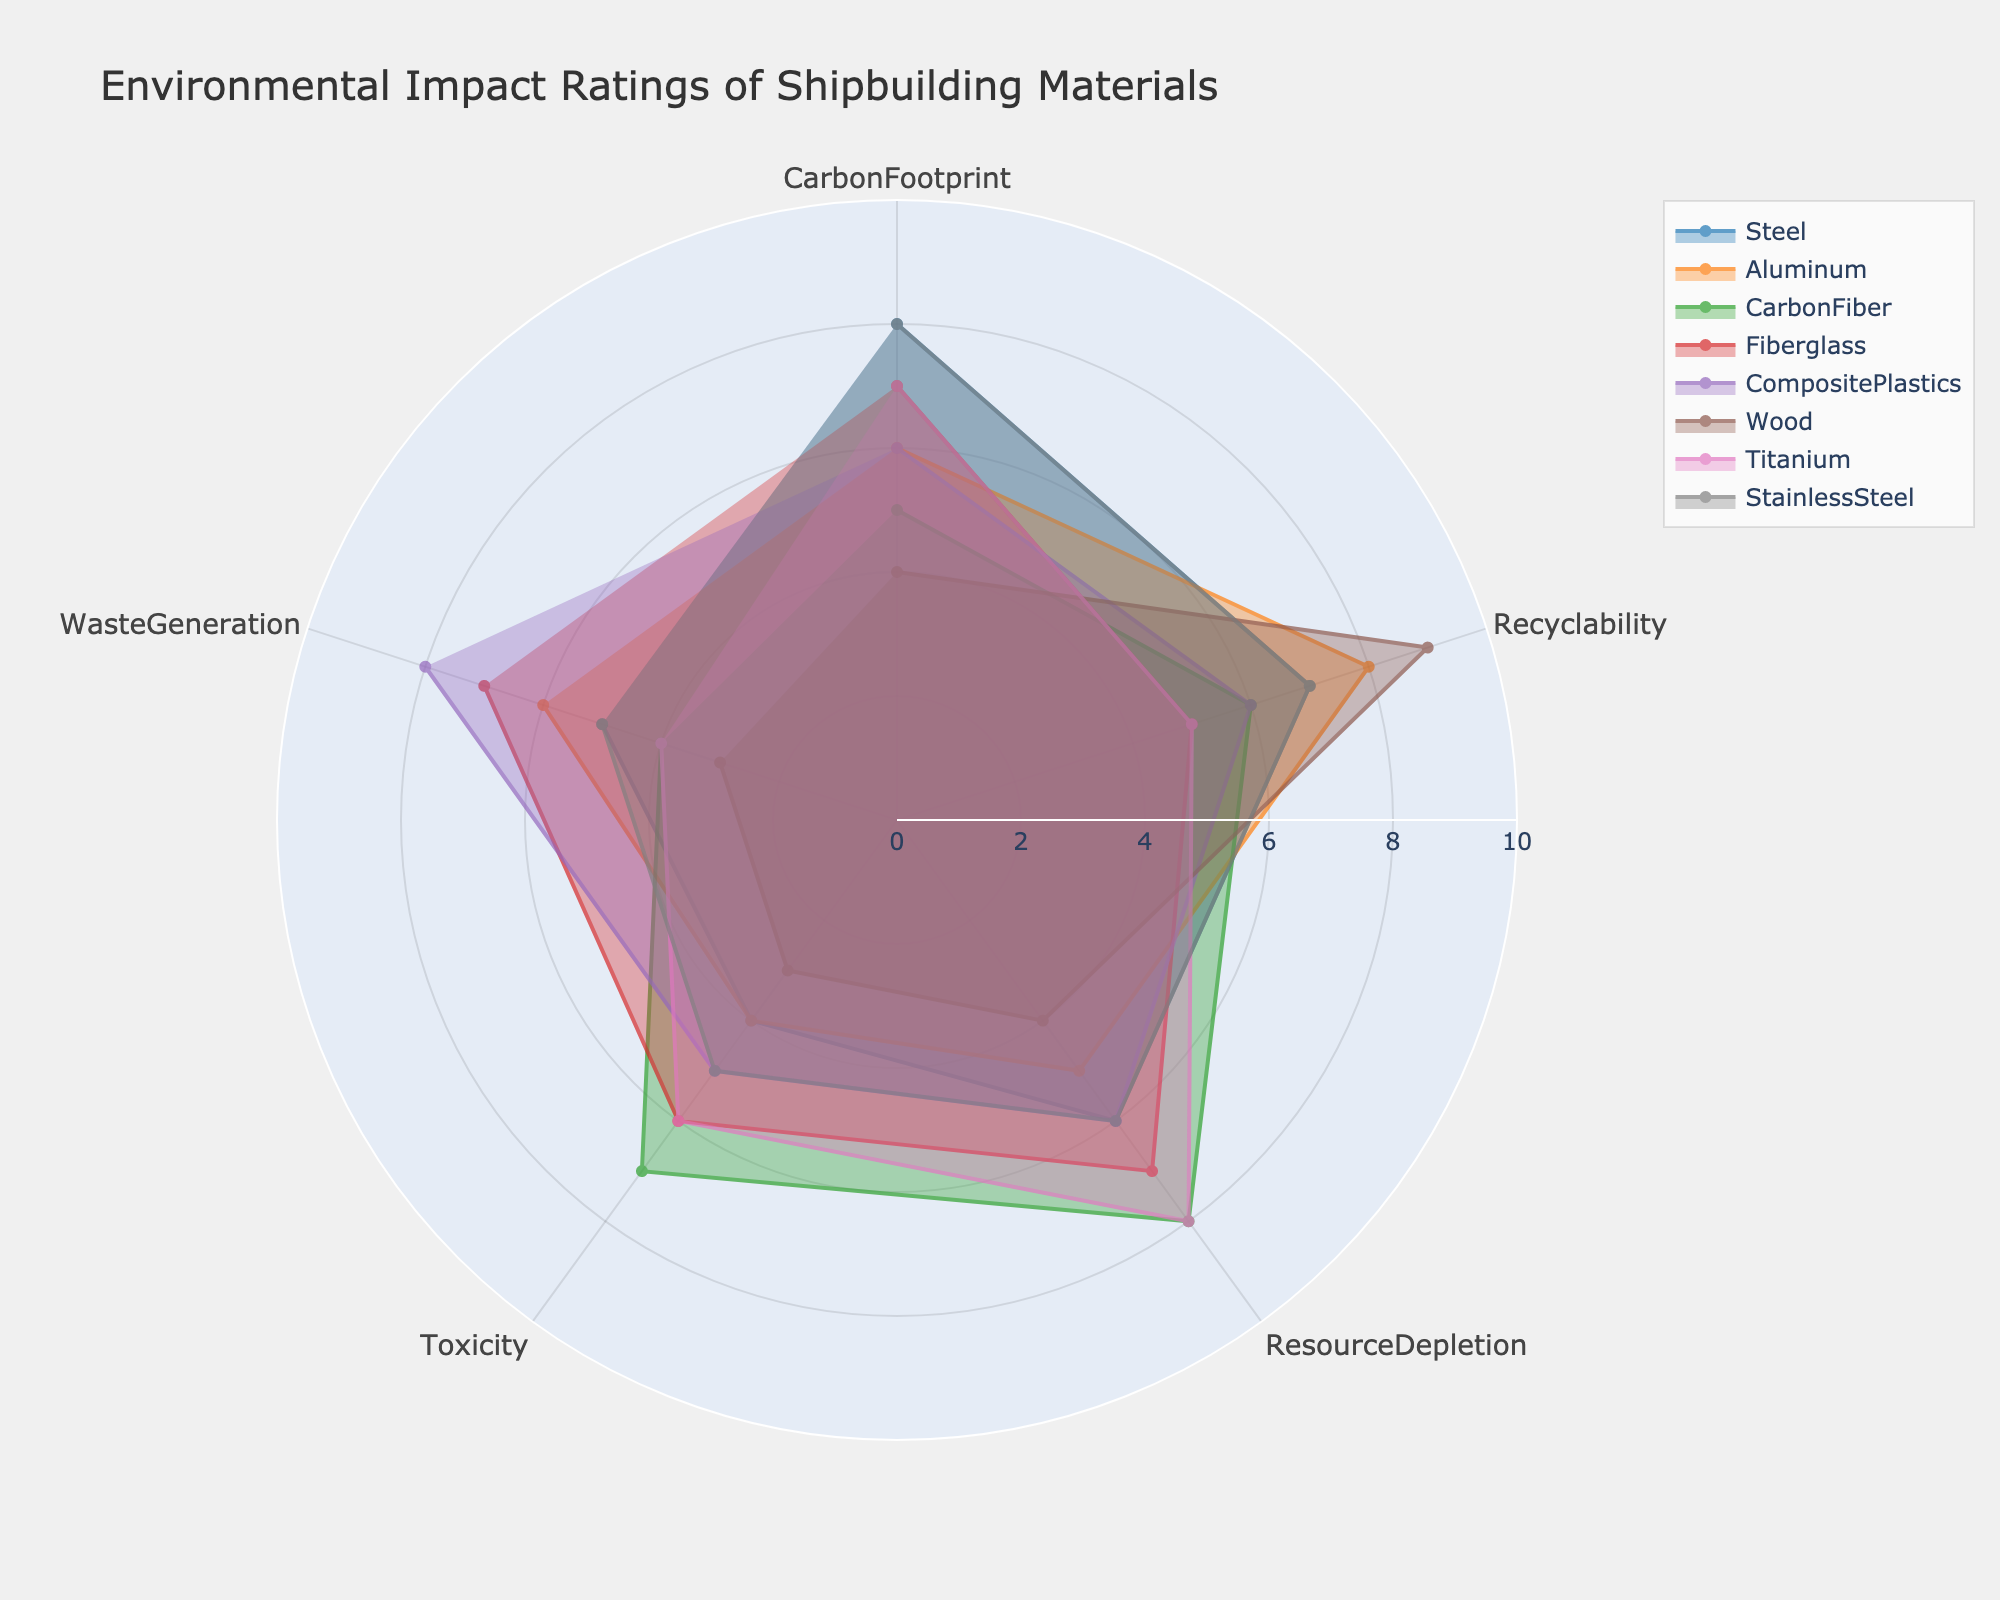How many materials are compared in the radar chart? Count the number of different materials listed in the legend of the radar chart.
Answer: 8 What is the title of the radar chart? Read the text located at the top of the chart, which typically serves as the title.
Answer: Environmental Impact Ratings of Shipbuilding Materials Which material has the highest recyclability rating? Look at the recyclability dimension (axis) and identify which material's polygon extends the furthest along that axis.
Answer: Wood How does the carbon footprint of Steel compare to that of Wood? Locate the values for the carbon footprint axis for both Steel and Wood, and then compare the two values numerically.
Answer: Steel has a higher carbon footprint than Wood Which material has the highest average rating across all categories? Calculate the average rating for each material by summing their ratings across all categories and dividing by the number of categories (5). Compare these averages to determine the highest one.
Answer: Steel (average 6) What is the overall trend in waste generation across all materials? Examine the Waste Generation axis and see how the ratings for this category vary across the materials.
Answer: Mostly between 3 and 8 Which material has the lowest toxicity, and what is its rating? Locate the toxicity axis and find the material whose rating extends the least along this axis.
Answer: Wood, 3 How do the environmental impact ratings of Aluminum and Titanium compare for resource depletion? Find the positions of Aluminum and Titanium on the Resource Depletion axis and compare their ratings.
Answer: Aluminum has a lower rating than Titanium What is the spread of ratings for CarbonFiber across all categories? Look at the positions of CarbonFiber on all axes and note its range of ratings from the lowest to the highest.
Answer: 4 to 8 If you were to choose a material based on the lowest average rating in Toxicity and Waste Generation, which material would it be and what would the average be? Calculate the average rating for each material in Toxicity and Waste Generation, then identify the material with the lowest average. Average for each material: Steel (4.5), Aluminum (5), CarbonFiber (5.5), Fiberglass (6.5), CompositePlastics (6.5), Wood (3), Titanium (5), StainlessSteel (5).
Answer: Wood, 3 